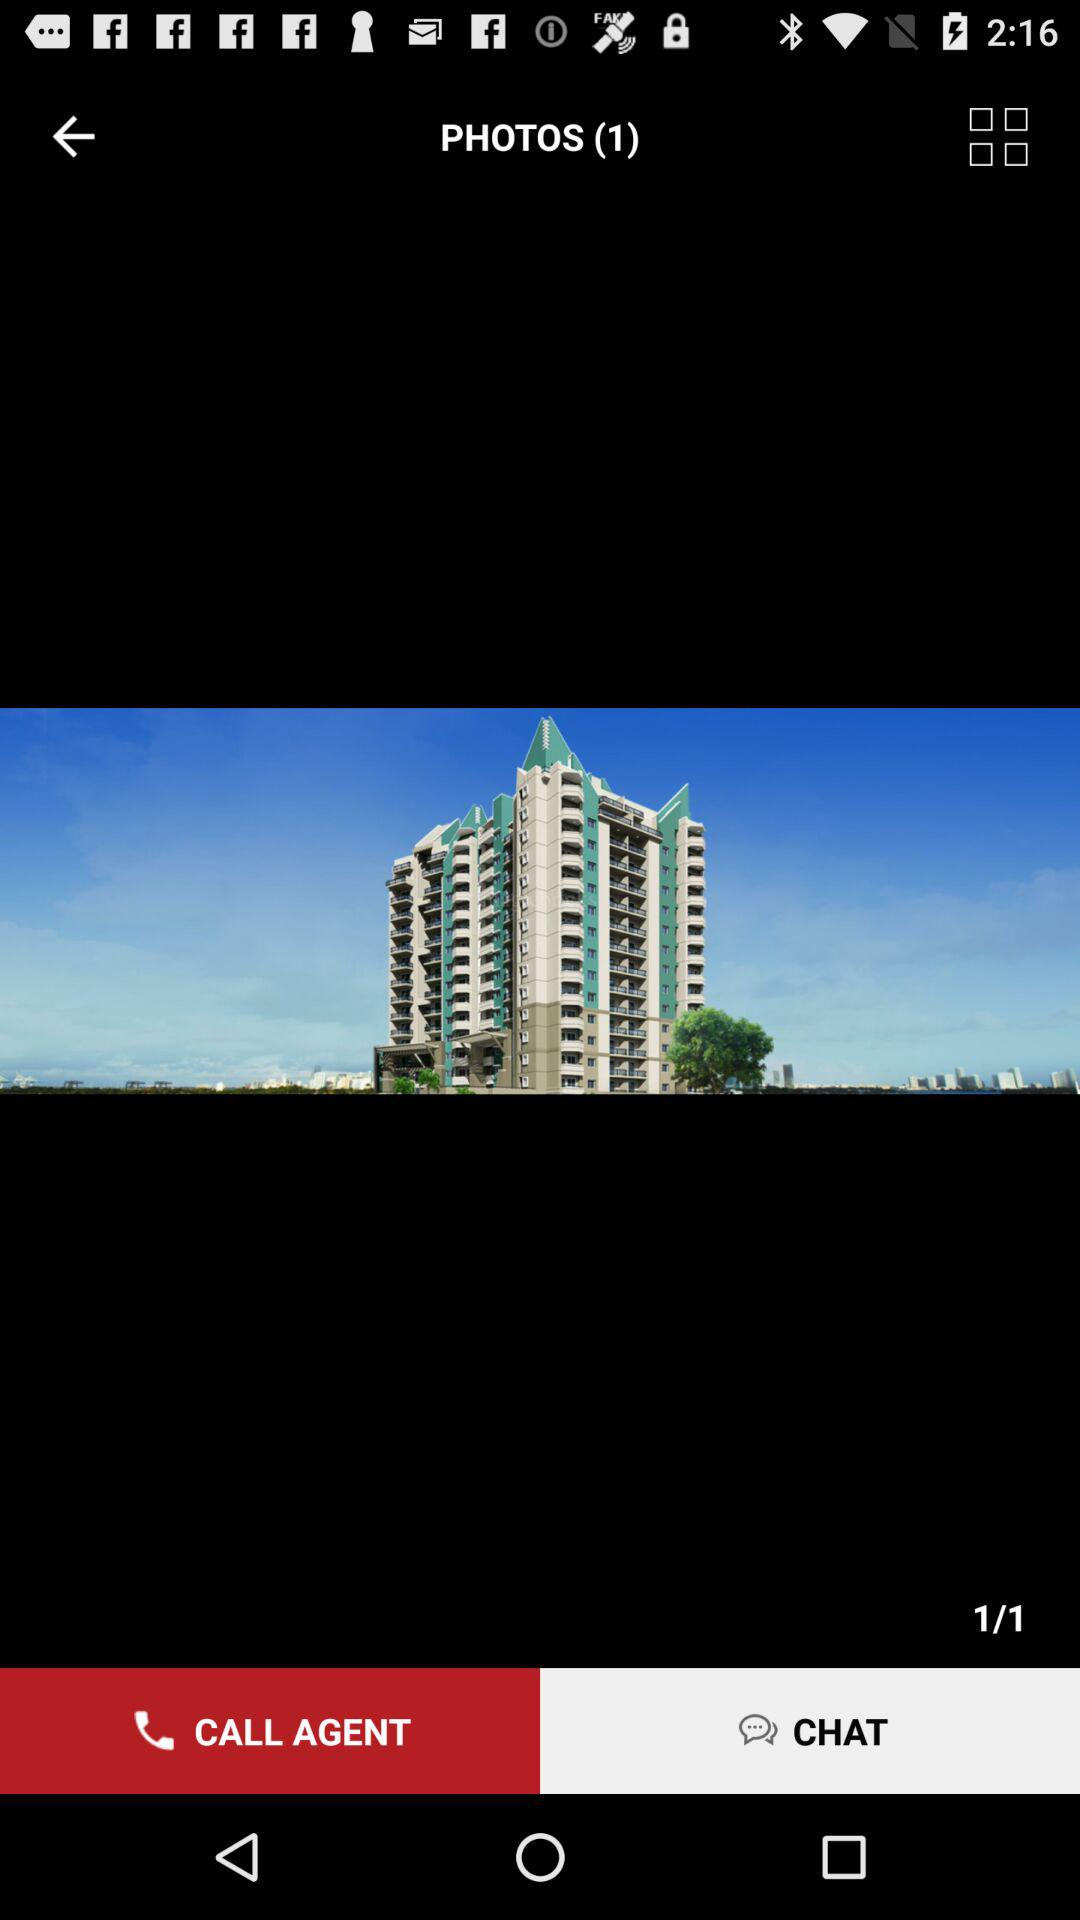Which slide are we currently on? You are on slide 1. 